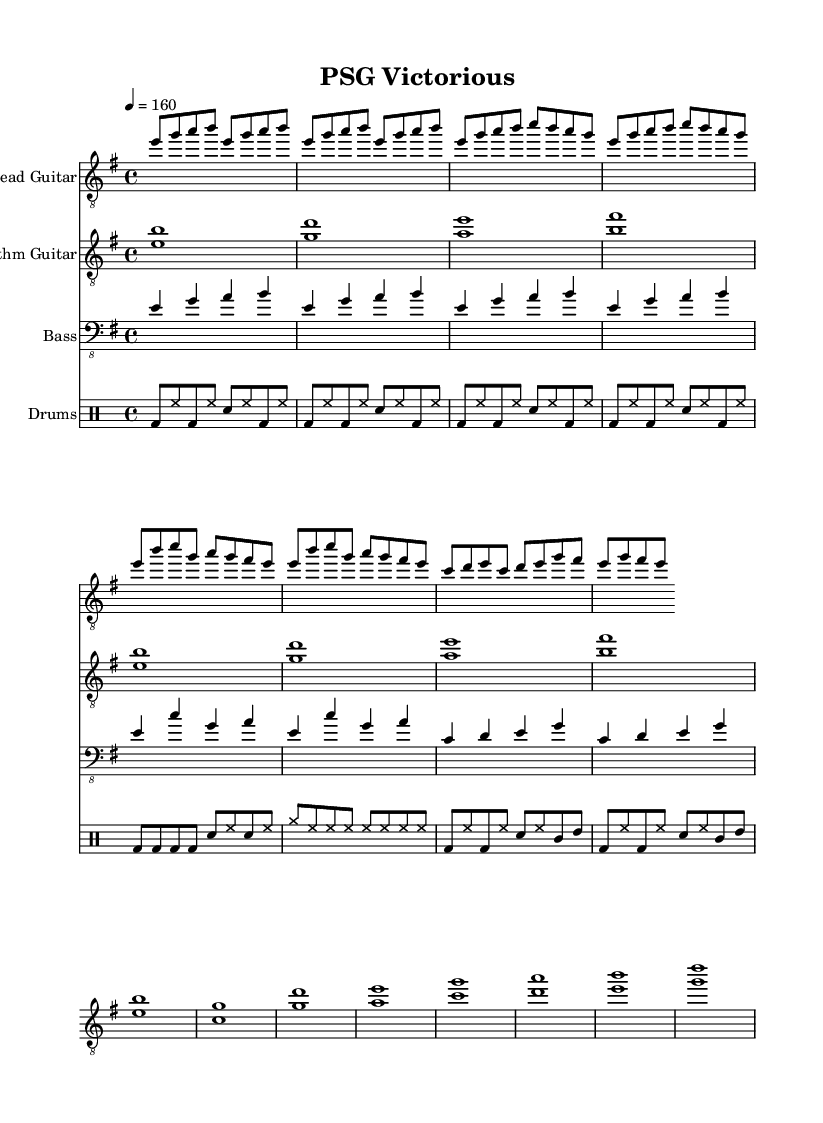What is the key signature of this music? The key signature is E minor, indicated at the beginning of the score with a relevant number of sharps. This can be seen in the global section of the LilyPond code, which defines the music's tonality.
Answer: E minor What is the time signature of this music? The time signature is 4/4, also noted in the global section of the score. This indicates that there are four beats in each measure, with a quarter note receiving one beat.
Answer: 4/4 What is the tempo of this music? The tempo is set at 160 beats per minute, which can be found in the global section as well. This indicates a relatively fast pace for the song, aligning with typical metal music characteristics.
Answer: 160 How many measures are in the chorus section? The chorus section contains 4 measures, as can be counted from the sheet music provided. Each line in the chorus can be broken down into groups of four beats, with 4 measures total in that section.
Answer: 4 What instruments are present in this piece? The piece includes Lead Guitar, Rhythm Guitar, Bass, and Drums. Each instrument has a designated staff, which is specified in the score layout code. Each is designed to contribute to the cohesive sound typical of metal music.
Answer: Lead Guitar, Rhythm Guitar, Bass, Drums What type of rhythm patterns are used in the drums part? The drum part consists of a mix of bass drum and hi-hats in the intro and verse, while the chorus features more emphasis on the bass drum with cymbals. This is common in metal, where dynamic rhythm plays a crucial role in the energy of the performance.
Answer: Mix of bass and hi-hats, emphasis on bass What is the overall mood conveyed by the sheet music structure? The overall mood is intense and energetic, typical of metal music, characterized by driving rhythms, aggressive melodies, and powerful dynamics. This can be inferred from the tempo, rhythmic patterns, and structure of the piece, which celebrates soccer victories.
Answer: Intense and energetic 